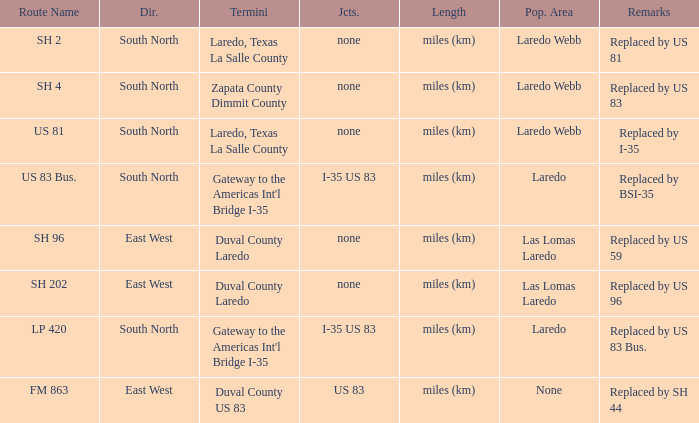How many termini are there that have "east west" listed in their direction section, "none" listed in their junction section, and have a route name of "sh 202"? 1.0. 